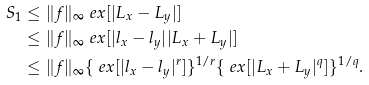<formula> <loc_0><loc_0><loc_500><loc_500>S _ { 1 } & \leq \| f \| _ { \infty } \ e x [ | L _ { x } - L _ { y } | ] \\ & \leq \| f \| _ { \infty } \ e x [ | l _ { x } - l _ { y } | | L _ { x } + L _ { y } | ] \\ & \leq \| f \| _ { \infty } \{ \ e x [ | l _ { x } - l _ { y } | ^ { r } ] \} ^ { 1 / r } \{ \ e x [ | L _ { x } + L _ { y } | ^ { q } ] \} ^ { 1 / q } .</formula> 